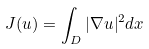Convert formula to latex. <formula><loc_0><loc_0><loc_500><loc_500>J ( u ) = \int _ { D } | \nabla u | ^ { 2 } d x</formula> 